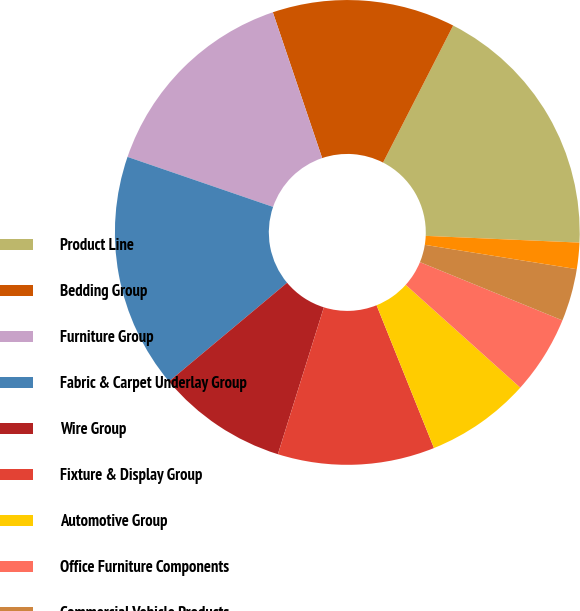<chart> <loc_0><loc_0><loc_500><loc_500><pie_chart><fcel>Product Line<fcel>Bedding Group<fcel>Furniture Group<fcel>Fabric & Carpet Underlay Group<fcel>Wire Group<fcel>Fixture & Display Group<fcel>Automotive Group<fcel>Office Furniture Components<fcel>Commercial Vehicle Products<fcel>Machinery Group<nl><fcel>18.17%<fcel>12.72%<fcel>14.54%<fcel>16.35%<fcel>9.09%<fcel>10.91%<fcel>7.28%<fcel>5.46%<fcel>3.65%<fcel>1.83%<nl></chart> 